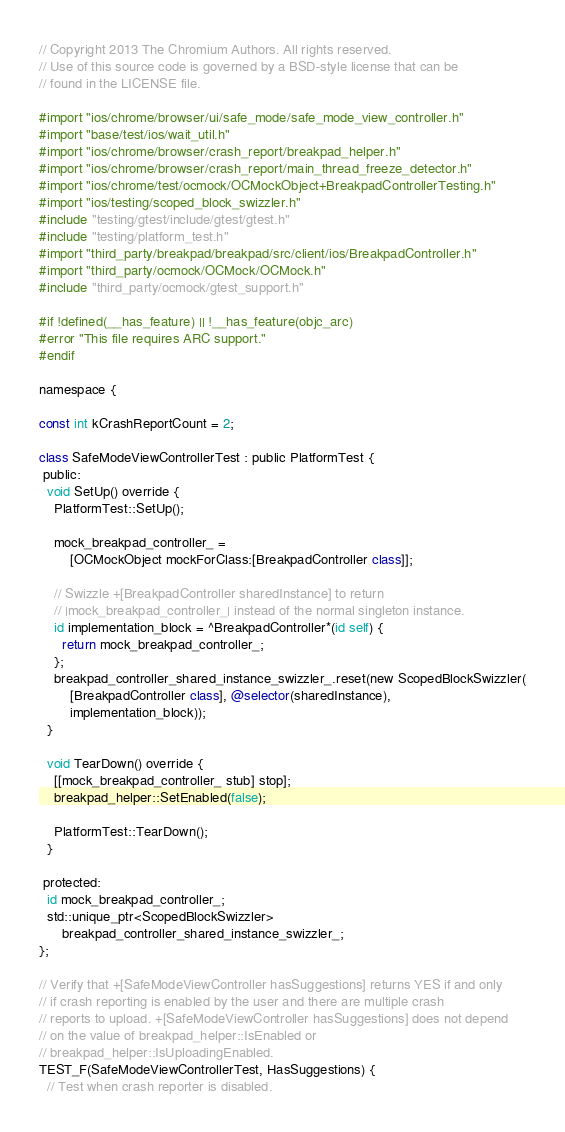Convert code to text. <code><loc_0><loc_0><loc_500><loc_500><_ObjectiveC_>// Copyright 2013 The Chromium Authors. All rights reserved.
// Use of this source code is governed by a BSD-style license that can be
// found in the LICENSE file.

#import "ios/chrome/browser/ui/safe_mode/safe_mode_view_controller.h"
#import "base/test/ios/wait_util.h"
#import "ios/chrome/browser/crash_report/breakpad_helper.h"
#import "ios/chrome/browser/crash_report/main_thread_freeze_detector.h"
#import "ios/chrome/test/ocmock/OCMockObject+BreakpadControllerTesting.h"
#import "ios/testing/scoped_block_swizzler.h"
#include "testing/gtest/include/gtest/gtest.h"
#include "testing/platform_test.h"
#import "third_party/breakpad/breakpad/src/client/ios/BreakpadController.h"
#import "third_party/ocmock/OCMock/OCMock.h"
#include "third_party/ocmock/gtest_support.h"

#if !defined(__has_feature) || !__has_feature(objc_arc)
#error "This file requires ARC support."
#endif

namespace {

const int kCrashReportCount = 2;

class SafeModeViewControllerTest : public PlatformTest {
 public:
  void SetUp() override {
    PlatformTest::SetUp();

    mock_breakpad_controller_ =
        [OCMockObject mockForClass:[BreakpadController class]];

    // Swizzle +[BreakpadController sharedInstance] to return
    // |mock_breakpad_controller_| instead of the normal singleton instance.
    id implementation_block = ^BreakpadController*(id self) {
      return mock_breakpad_controller_;
    };
    breakpad_controller_shared_instance_swizzler_.reset(new ScopedBlockSwizzler(
        [BreakpadController class], @selector(sharedInstance),
        implementation_block));
  }

  void TearDown() override {
    [[mock_breakpad_controller_ stub] stop];
    breakpad_helper::SetEnabled(false);

    PlatformTest::TearDown();
  }

 protected:
  id mock_breakpad_controller_;
  std::unique_ptr<ScopedBlockSwizzler>
      breakpad_controller_shared_instance_swizzler_;
};

// Verify that +[SafeModeViewController hasSuggestions] returns YES if and only
// if crash reporting is enabled by the user and there are multiple crash
// reports to upload. +[SafeModeViewController hasSuggestions] does not depend
// on the value of breakpad_helper::IsEnabled or
// breakpad_helper::IsUploadingEnabled.
TEST_F(SafeModeViewControllerTest, HasSuggestions) {
  // Test when crash reporter is disabled.</code> 